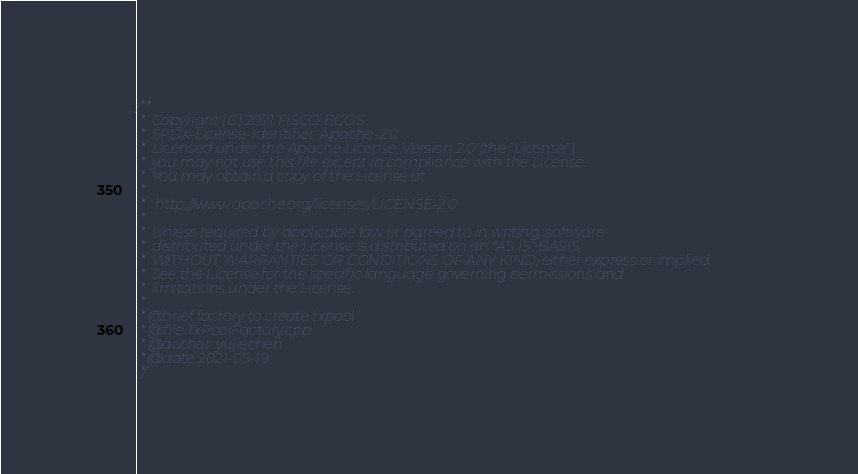<code> <loc_0><loc_0><loc_500><loc_500><_C++_>/**
 *  Copyright (C) 2021 FISCO BCOS.
 *  SPDX-License-Identifier: Apache-2.0
 *  Licensed under the Apache License, Version 2.0 (the "License");
 *  you may not use this file except in compliance with the License.
 *  You may obtain a copy of the License at
 *
 *   http://www.apache.org/licenses/LICENSE-2.0
 *
 *  Unless required by applicable law or agreed to in writing, software
 *  distributed under the License is distributed on an "AS IS" BASIS,
 *  WITHOUT WARRANTIES OR CONDITIONS OF ANY KIND, either express or implied.
 *  See the License for the specific language governing permissions and
 *  limitations under the License.
 *
 * @brief factory to create txpool
 * @file TxPoolFactory.cpp
 * @author: yujiechen
 * @date 2021-05-19
 */</code> 